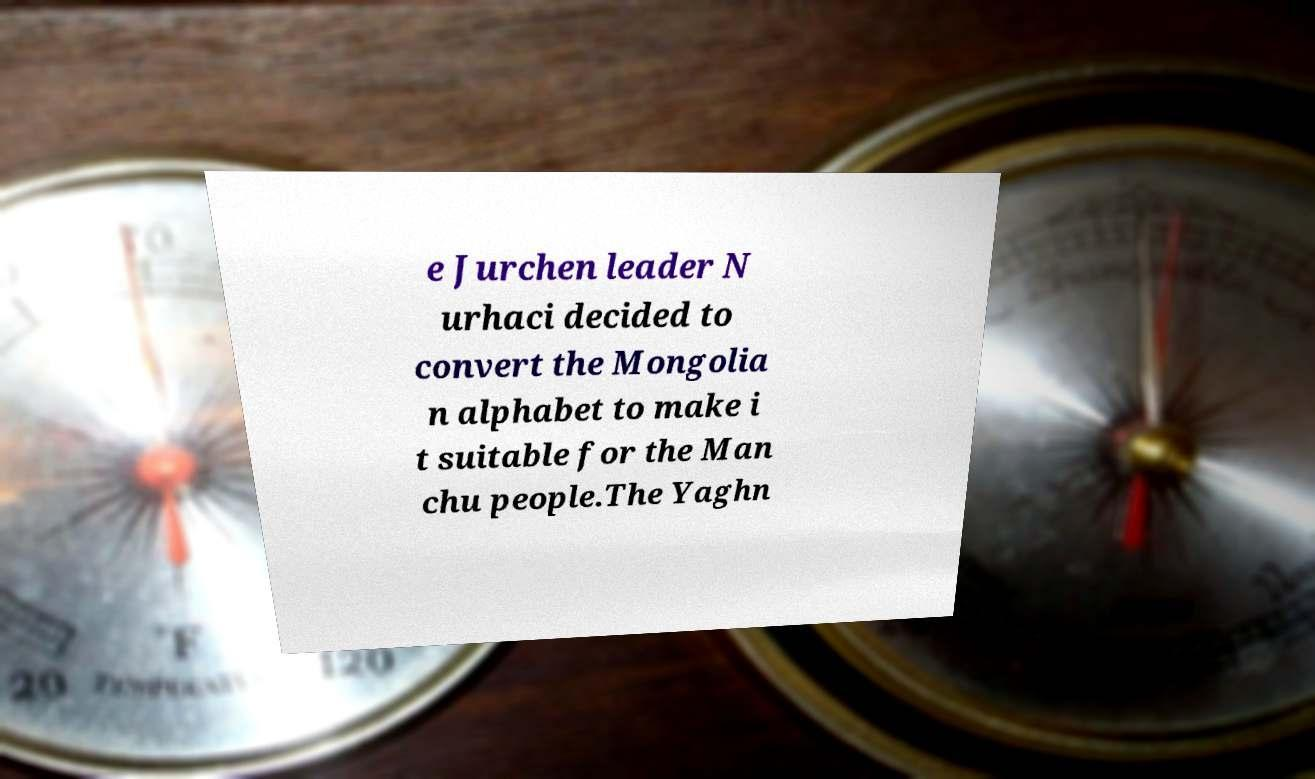There's text embedded in this image that I need extracted. Can you transcribe it verbatim? e Jurchen leader N urhaci decided to convert the Mongolia n alphabet to make i t suitable for the Man chu people.The Yaghn 